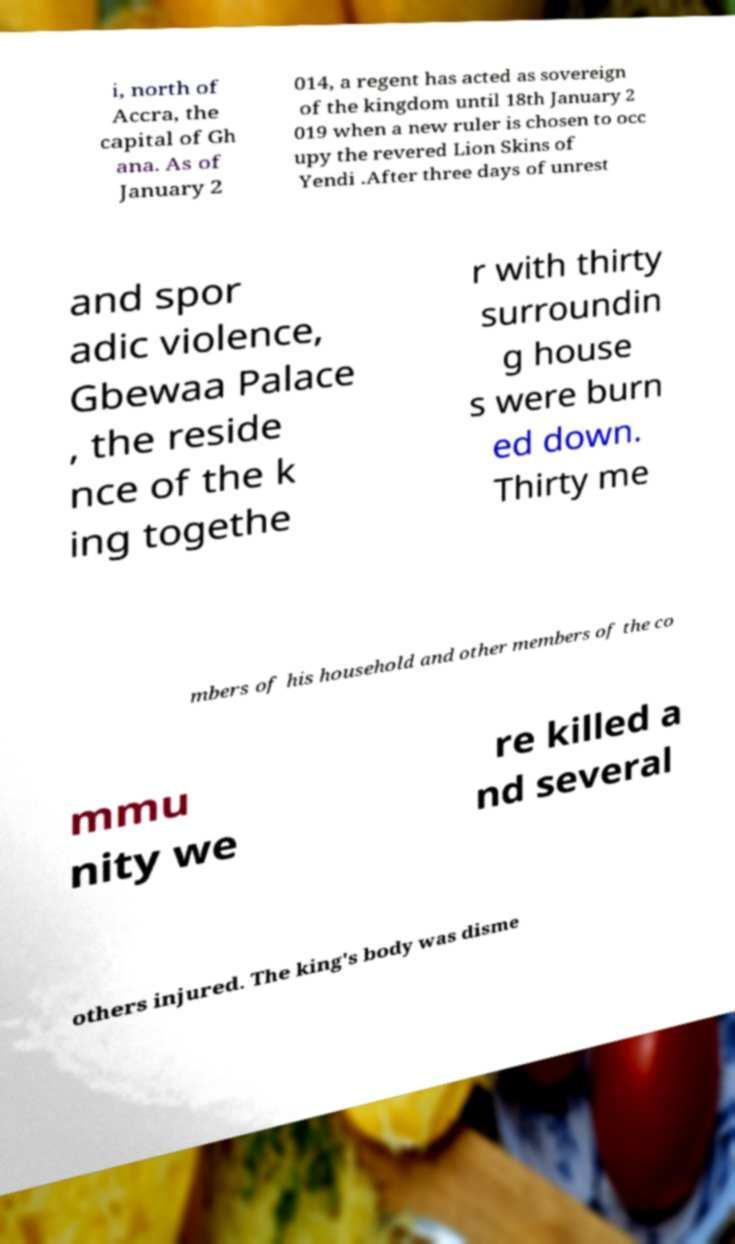For documentation purposes, I need the text within this image transcribed. Could you provide that? i, north of Accra, the capital of Gh ana. As of January 2 014, a regent has acted as sovereign of the kingdom until 18th January 2 019 when a new ruler is chosen to occ upy the revered Lion Skins of Yendi .After three days of unrest and spor adic violence, Gbewaa Palace , the reside nce of the k ing togethe r with thirty surroundin g house s were burn ed down. Thirty me mbers of his household and other members of the co mmu nity we re killed a nd several others injured. The king's body was disme 